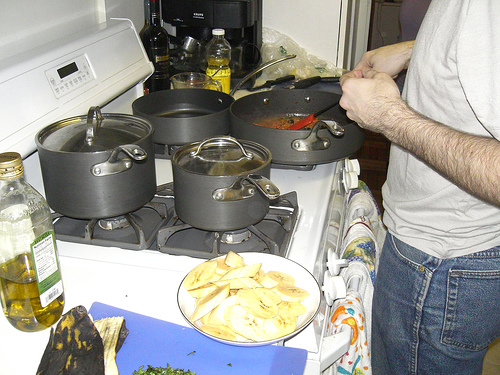<image>
Can you confirm if the plate is next to the man? Yes. The plate is positioned adjacent to the man, located nearby in the same general area. 